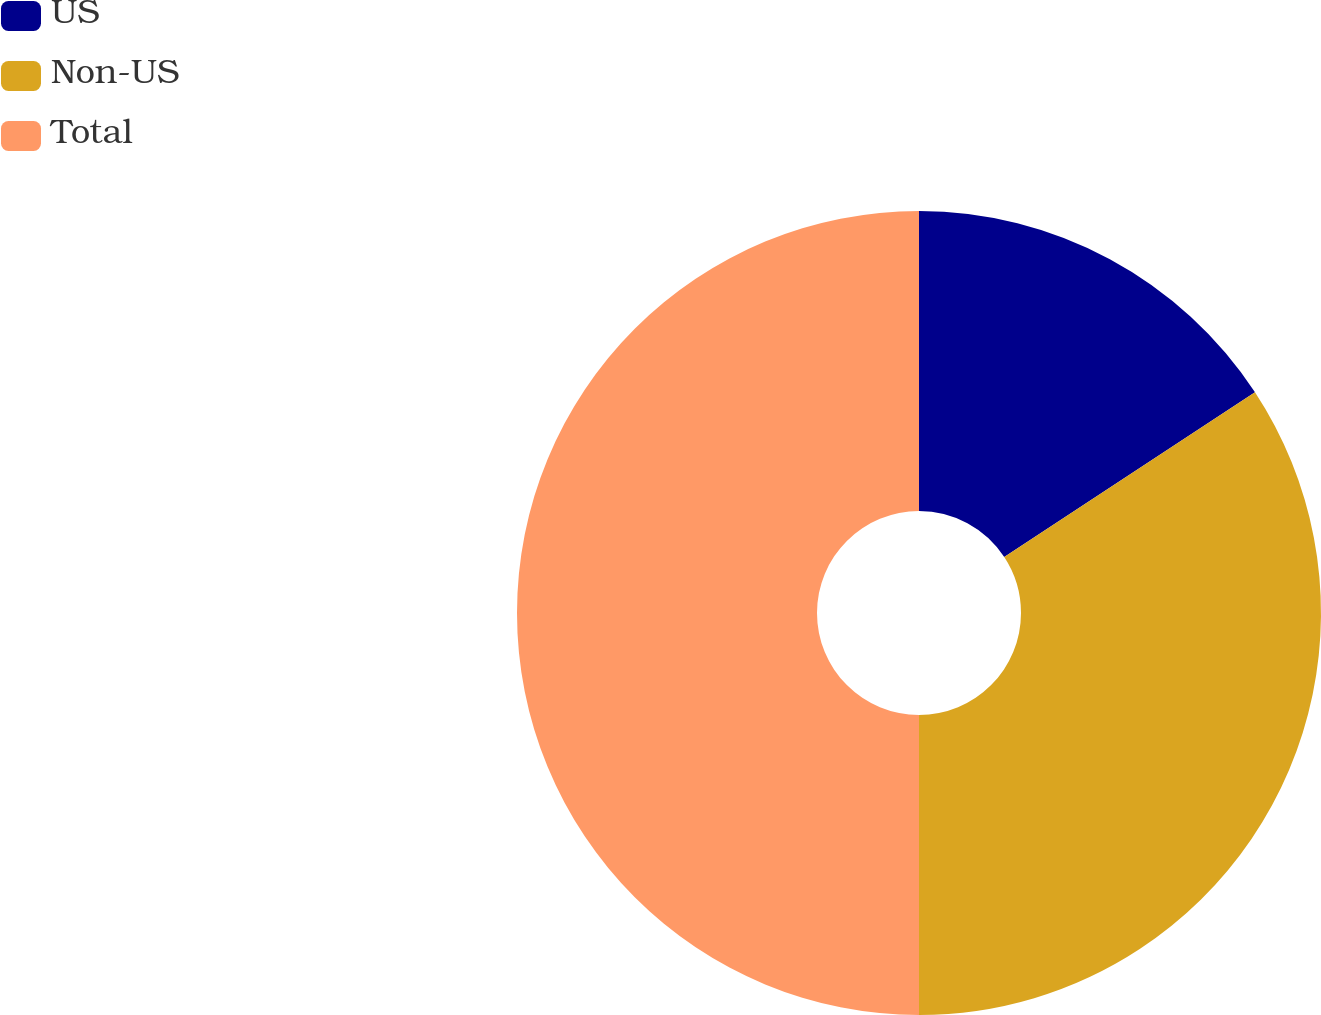<chart> <loc_0><loc_0><loc_500><loc_500><pie_chart><fcel>US<fcel>Non-US<fcel>Total<nl><fcel>15.75%<fcel>34.25%<fcel>50.0%<nl></chart> 